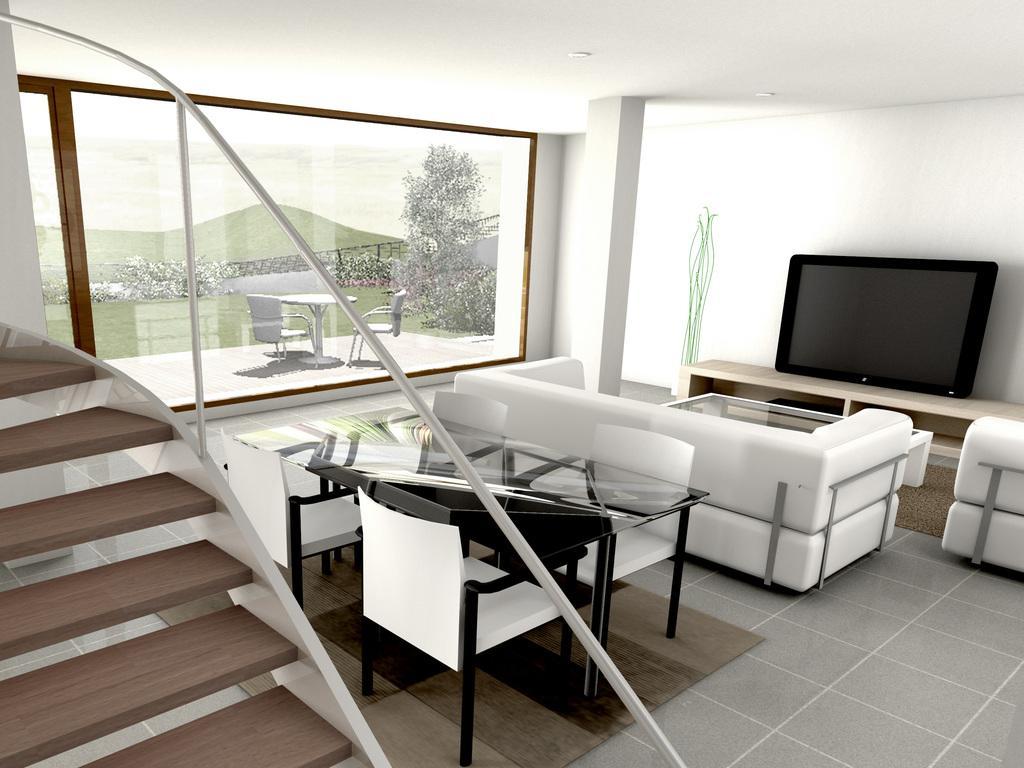Can you describe this image briefly? This image is clicked in a room. There are sofas in white color. In the front, there is desk on which TV is kept. To the left, there are stairs. At the bottom, there is a floor. Beside the sofa there is a table along with chairs. In the background, there is window. 